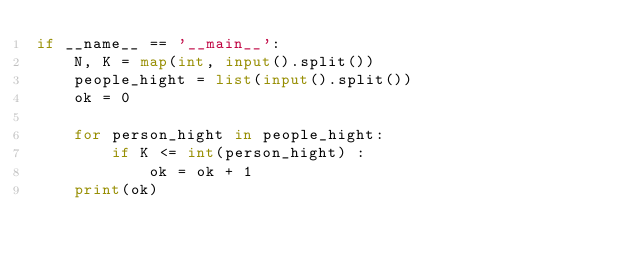Convert code to text. <code><loc_0><loc_0><loc_500><loc_500><_Python_>if __name__ == '__main__':
    N, K = map(int, input().split())
    people_hight = list(input().split())
    ok = 0

    for person_hight in people_hight:
        if K <= int(person_hight) :
            ok = ok + 1
    print(ok)</code> 